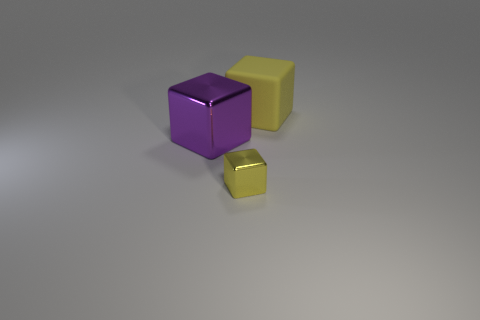Add 3 yellow objects. How many objects exist? 6 Subtract 0 yellow spheres. How many objects are left? 3 Subtract all large shiny blocks. Subtract all big yellow rubber cubes. How many objects are left? 1 Add 1 big yellow rubber blocks. How many big yellow rubber blocks are left? 2 Add 2 small green metallic cylinders. How many small green metallic cylinders exist? 2 